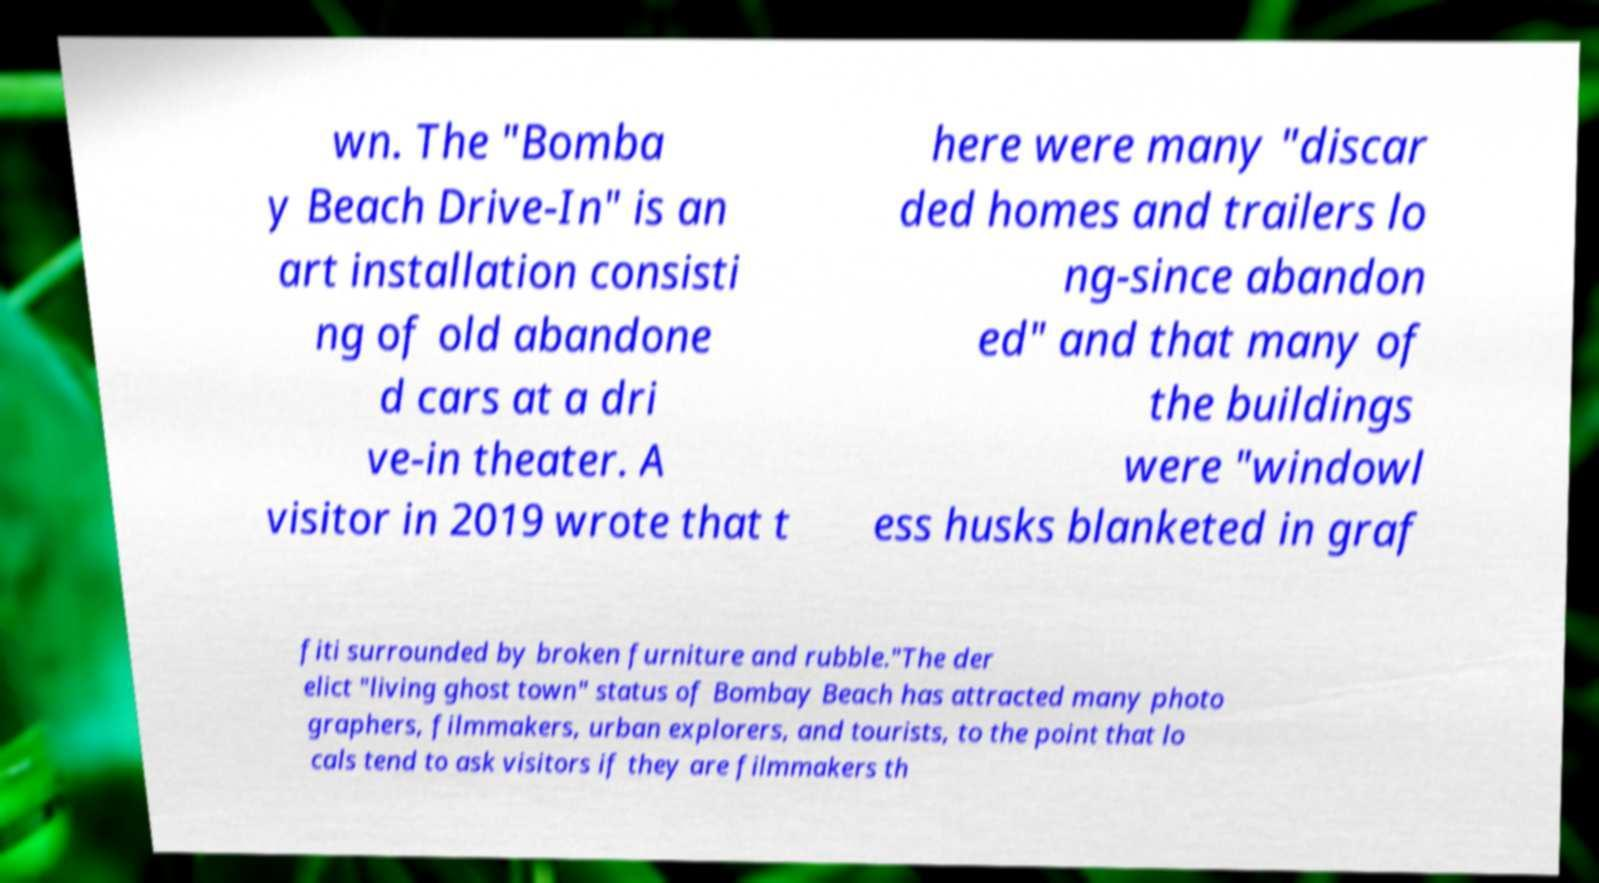There's text embedded in this image that I need extracted. Can you transcribe it verbatim? wn. The "Bomba y Beach Drive-In" is an art installation consisti ng of old abandone d cars at a dri ve-in theater. A visitor in 2019 wrote that t here were many "discar ded homes and trailers lo ng-since abandon ed" and that many of the buildings were "windowl ess husks blanketed in graf fiti surrounded by broken furniture and rubble."The der elict "living ghost town" status of Bombay Beach has attracted many photo graphers, filmmakers, urban explorers, and tourists, to the point that lo cals tend to ask visitors if they are filmmakers th 